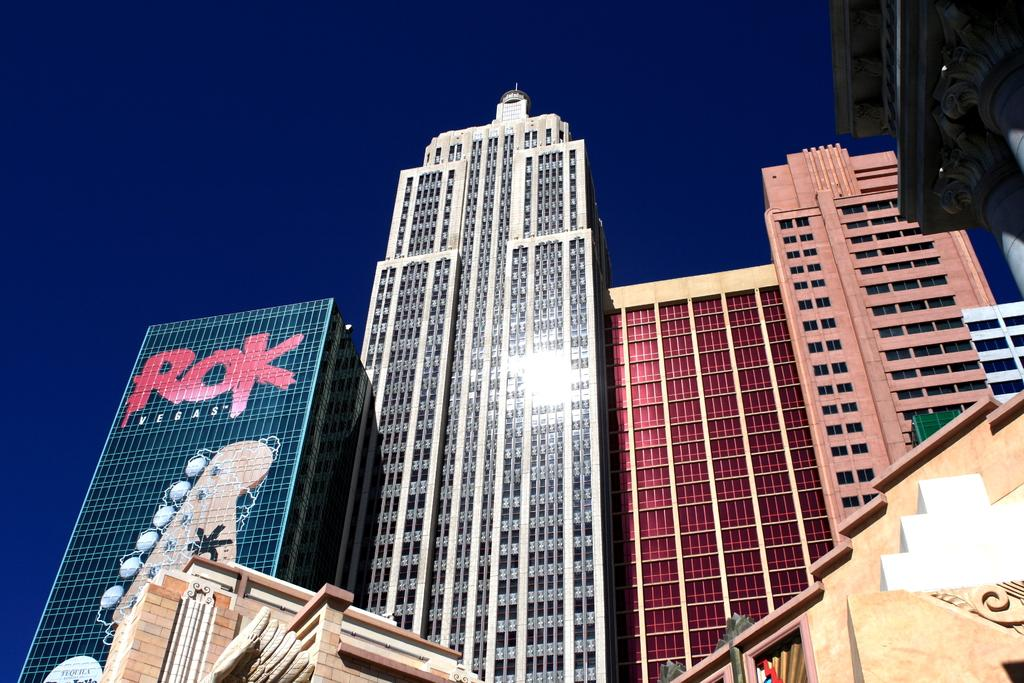What type of structures are present in the image? There are buildings in the image. Where are the buildings located in the image? The buildings are at the top of the image. What else can be seen in the image besides the buildings? The sky is visible at the top of the image. Can you see any zebras playing volleyball in the image? No, there are no zebras or volleyball games present in the image. 